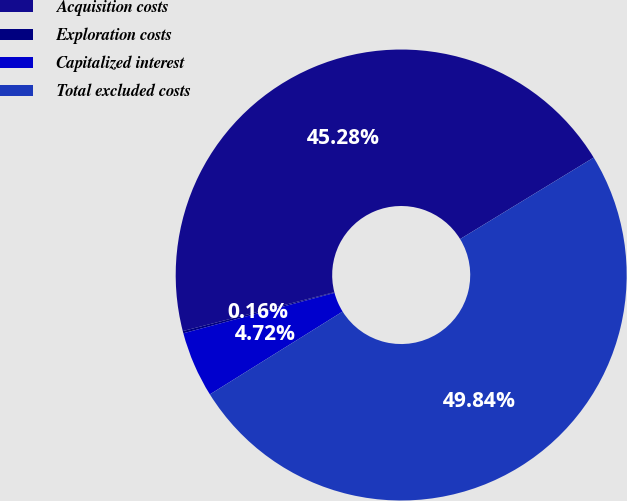<chart> <loc_0><loc_0><loc_500><loc_500><pie_chart><fcel>Acquisition costs<fcel>Exploration costs<fcel>Capitalized interest<fcel>Total excluded costs<nl><fcel>45.28%<fcel>0.16%<fcel>4.72%<fcel>49.84%<nl></chart> 